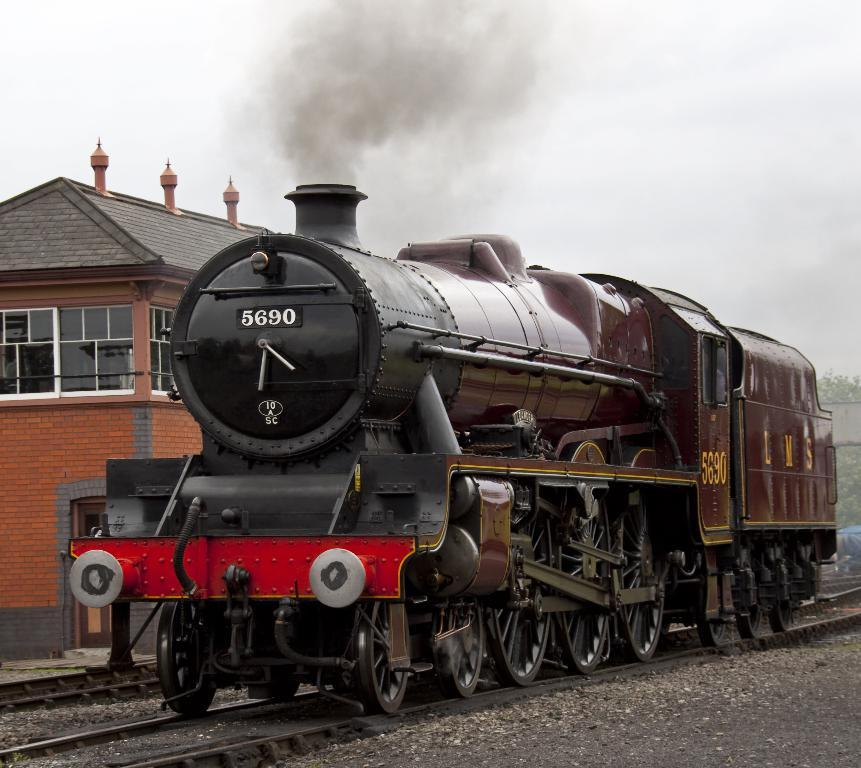What is the main subject of the image? The main subject of the image is an engine of a train. Where is the train engine located? The train engine is on the track. What can be seen behind the train engine? There is a building behind the train engine. What is visible in the background of the image? The sky is visible in the background of the image. What type of thread is being used to sew the camera in the image? There is no camera present in the image, and therefore no thread or sewing activity can be observed. 